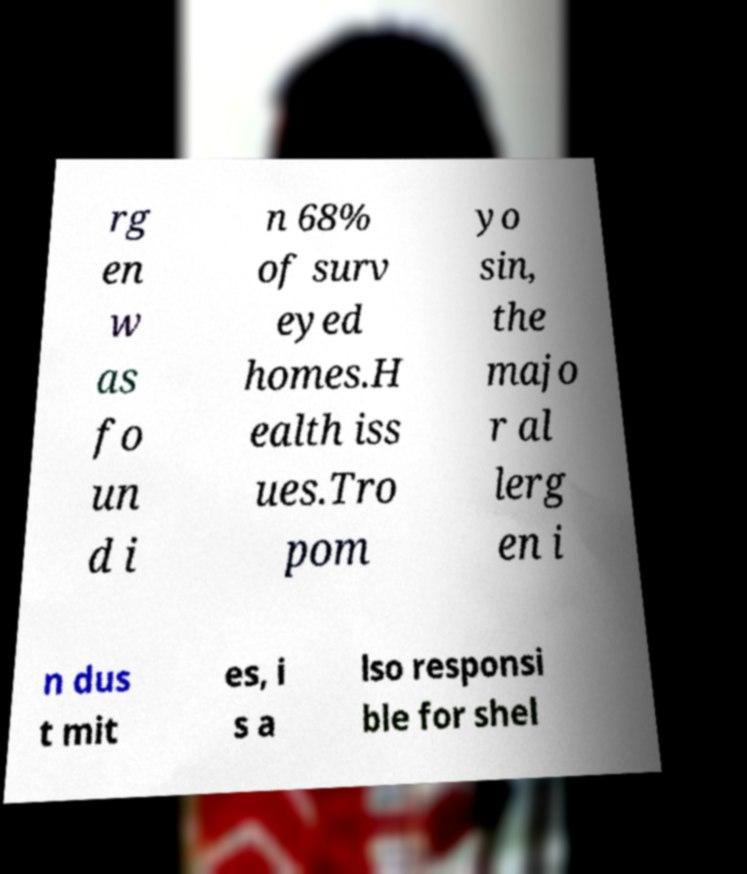Could you assist in decoding the text presented in this image and type it out clearly? rg en w as fo un d i n 68% of surv eyed homes.H ealth iss ues.Tro pom yo sin, the majo r al lerg en i n dus t mit es, i s a lso responsi ble for shel 